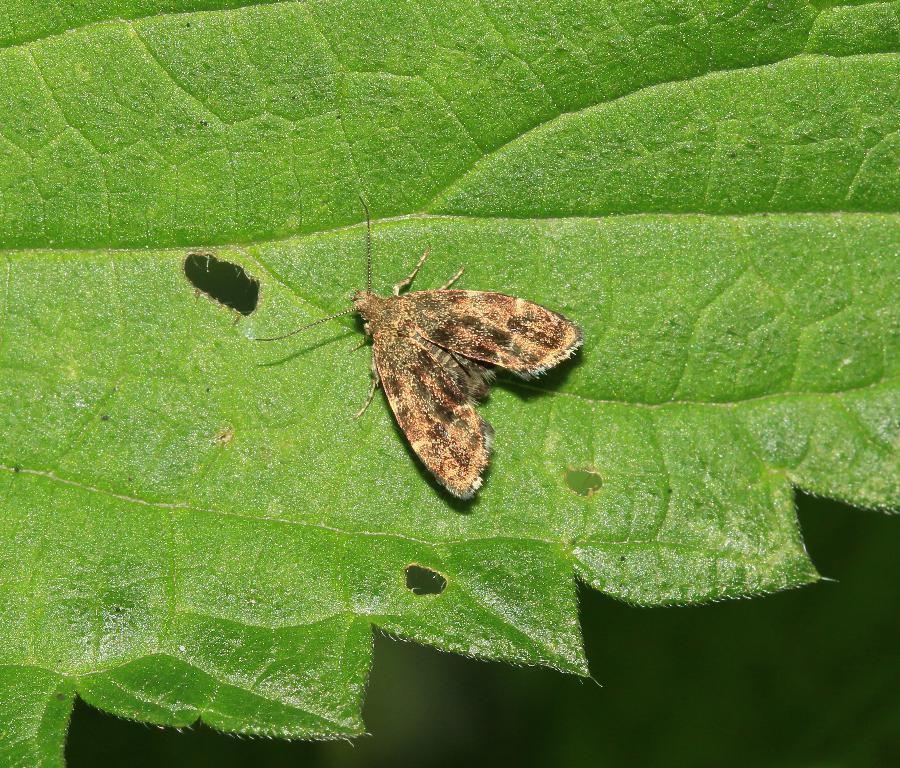In one or two sentences, can you explain what this image depicts? In this picture I can see the insect on the leaf. 